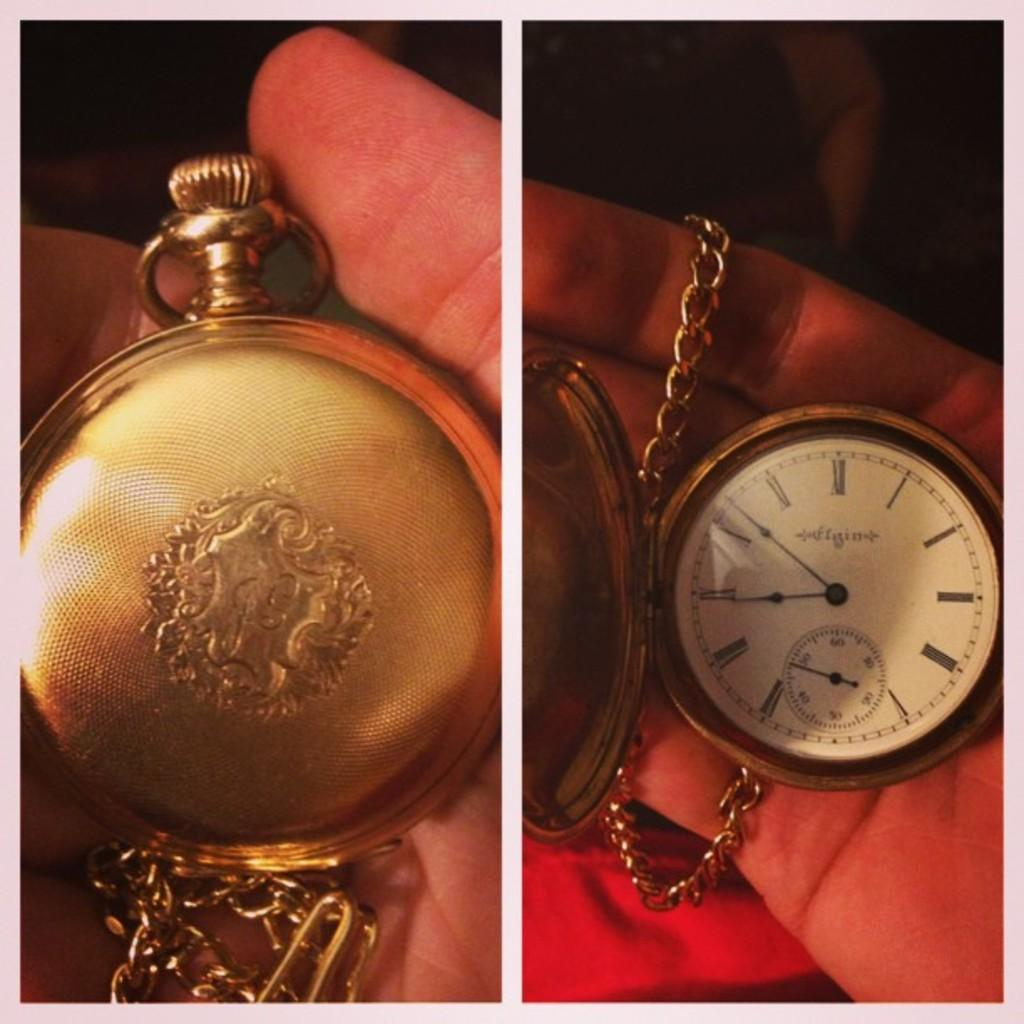<image>
Offer a succinct explanation of the picture presented. A gold pocket watch that that has an insignia Infigint. 